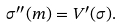Convert formula to latex. <formula><loc_0><loc_0><loc_500><loc_500>\sigma ^ { \prime \prime } ( m ) = V ^ { \prime } ( \sigma ) .</formula> 